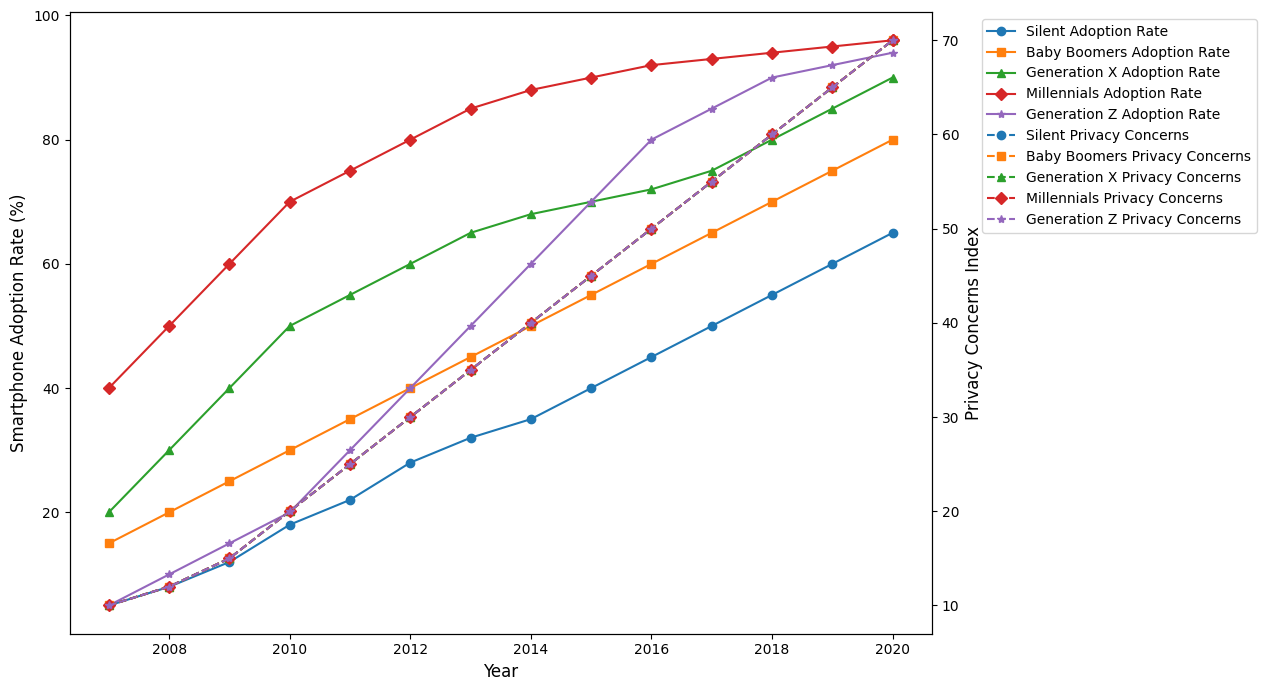What is the rate of smartphone adoption among Generation Z in 2015? Look at the curve for Generation Z and find the data point for the year 2015. The smartphone adoption rate for Generation Z in 2015 is at 70%.
Answer: 70% Which generation had the highest privacy concerns index in 2020? Look at the privacy concerns lines for all generations in the year 2020. All lines meet at a privacy concerns index of 70 in 2020, indicating that the privacy concerns index is the same for all generations in that year.
Answer: All generations Compare the smartphone adoption rate between Millennials and the Silent Generation in 2008. Which generation had a higher adoption rate and by how much? Look at the data points for Millennials and Silent Generation in 2008. Millennials' adoption rate is 50%, while Silent Generation's adoption rate is 8%. The difference is 50% - 8% = 42%. Millennials had a higher adoption rate by 42%.
Answer: Millennials, 42% What is the average privacy concerns index for Millennials between 2008 and 2012? Look at the privacy concerns index points for Millennials from 2008 to 2012: 12, 15, 20, 25, and 30. Sum them up: 12 + 15 + 20 + 25 + 30 = 102. Divide by the number of years: 102 / 5 = 20.4.
Answer: 20.4 In what year did Generation X have a smartphone adoption rate of 60%, and what was the corresponding privacy concerns index? Look at the curve for Generation X and find the year where the adoption rate reaches 60%. This occurs in 2012. The corresponding privacy concerns index for Generation X in 2012 is 30.
Answer: 2012, 30 Which generation shows the steepest increase in smartphone adoption rate from 2010 to 2011? Compare the slopes of the smartphone adoption rate lines from 2010 to 2011 for all generations. Generation Z grows from 20% to 30%, an increase of 10%. Millennials grow from 70% to 75%, an increase of 5%. Generation X grows from 50% to 55%, an increase of 5%. Baby Boomers grow from 30% to 35%, an increase of 5%. Silent Generation grows from 18% to 22%, an increase of 4%. Generation Z shows the steepest increase.
Answer: Generation Z How did the privacy concerns index for Baby Boomers change from 2015 to 2020, and what was the overall change in percentage? Look at the privacy concerns index for Baby Boomers for 2015 and 2020. The index in 2015 is 45 and in 2020 it is 70. The change is 70 - 45 = 25. To find the percentage change: (25 / 45) * 100% ≈ 55.56%.
Answer: 55.56% What was the overall trend for smartphone adoption rates for the Silent Generation from 2007 to 2020? Look at the entire curve for the Silent Generation from 2007 to 2020. The smartphone adoption rate consistently increases from 5% to 65%, indicating a steady upward trend.
Answer: Steady upward trend 